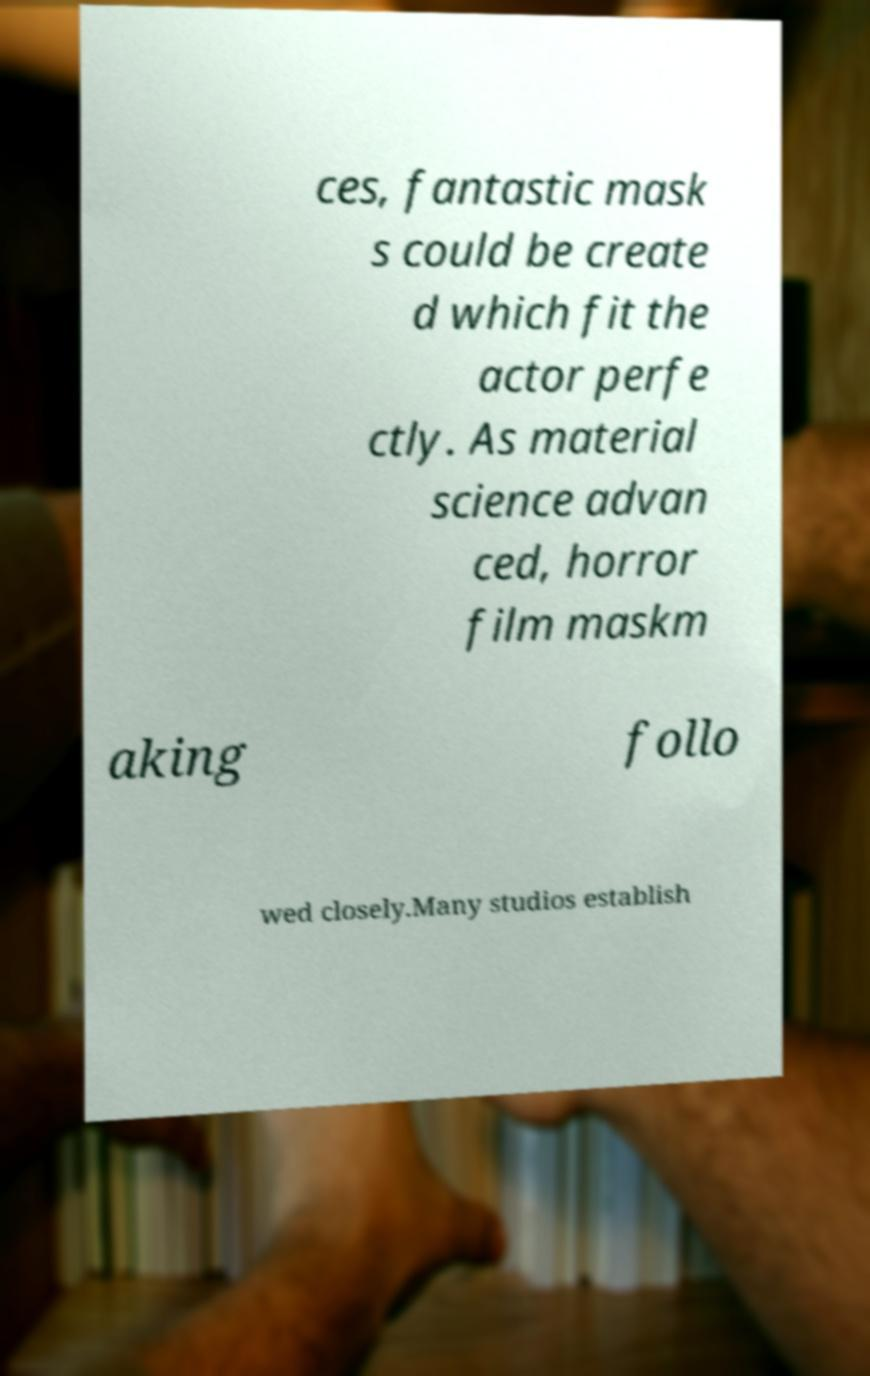Please identify and transcribe the text found in this image. ces, fantastic mask s could be create d which fit the actor perfe ctly. As material science advan ced, horror film maskm aking follo wed closely.Many studios establish 